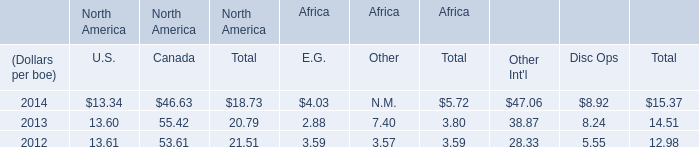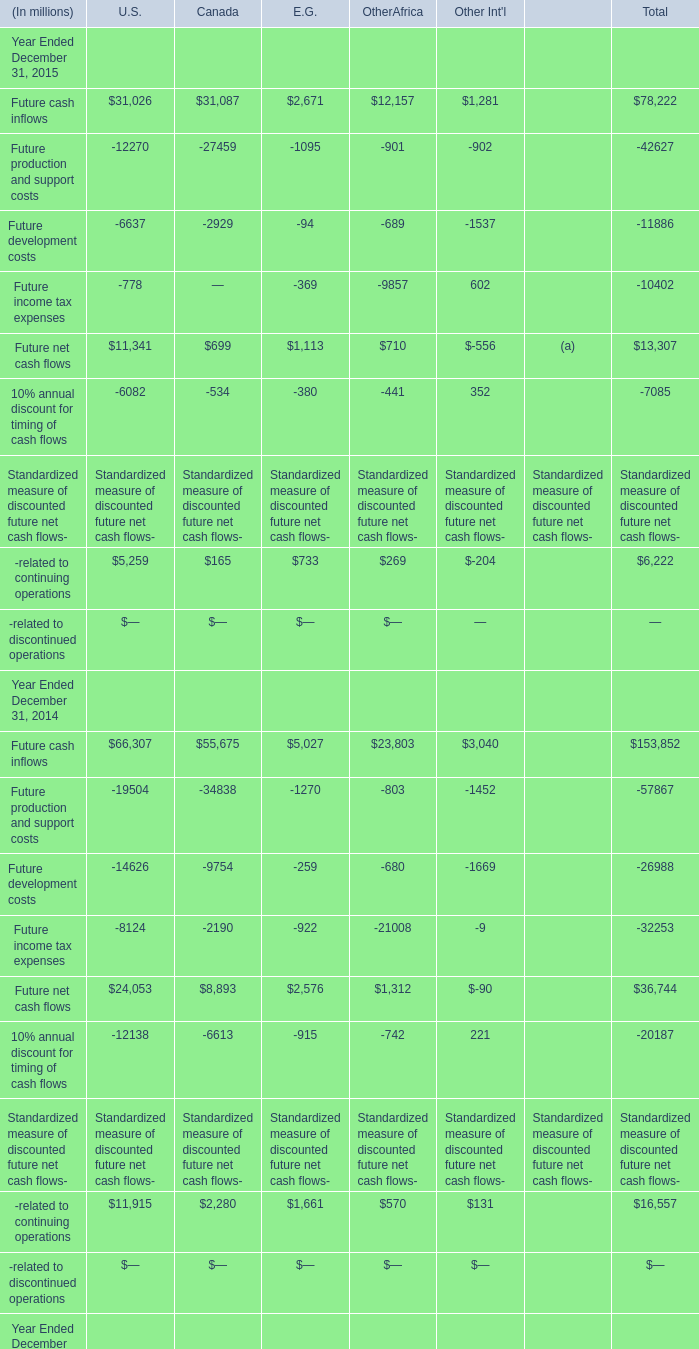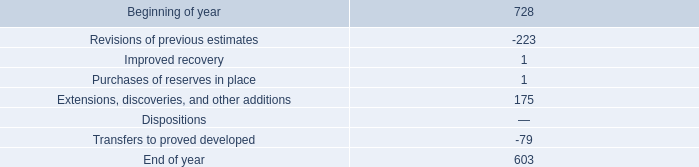how many of the year end 2015 proved undeveloped reserves were converted to proved developed reserves? 
Computations: (603 * 11%)
Answer: 66.33. 